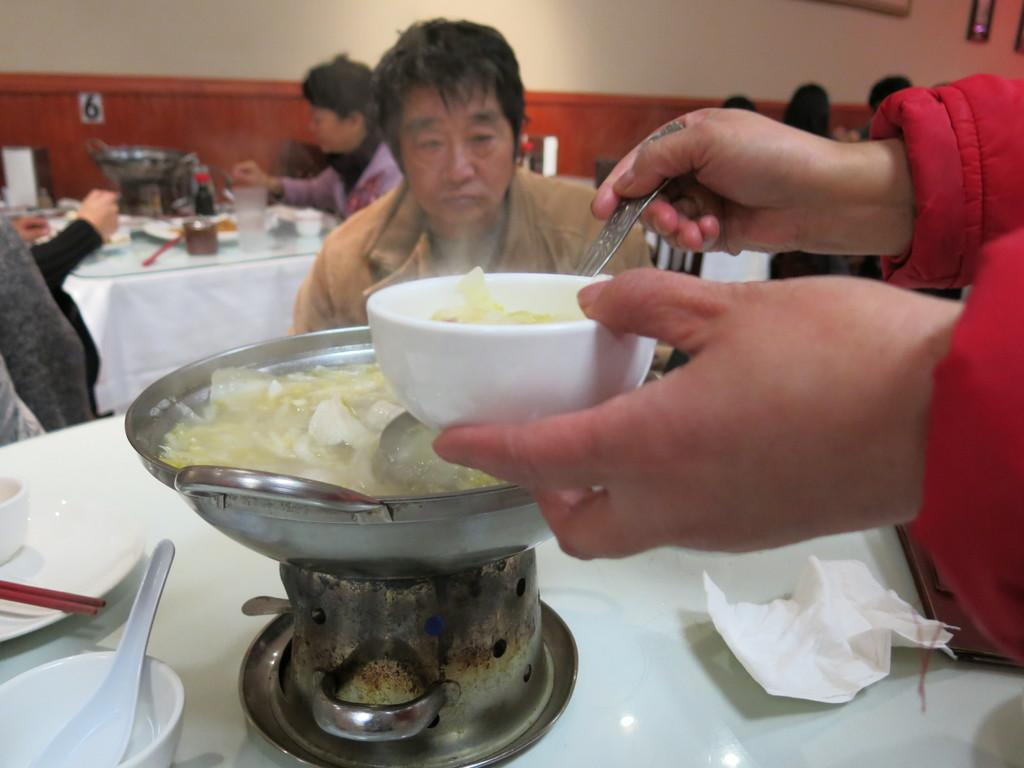How many people are in the group visible in the image? There is a group of persons in the image, but the exact number is not specified. What are the persons in the group doing in the image? The persons in the group are cooking in the image. What is in front of the chairs where the persons are sitting? There is a table in front of the chairs. What can be found on the table in the image? There are objects on the table. What is visible behind the group of persons? There is a wall visible in the image. What type of bell can be heard ringing in the image? There is no bell present or audible in the image. What direction are the persons in the group facing in the image? The image does not provide information about the direction the persons are facing. 